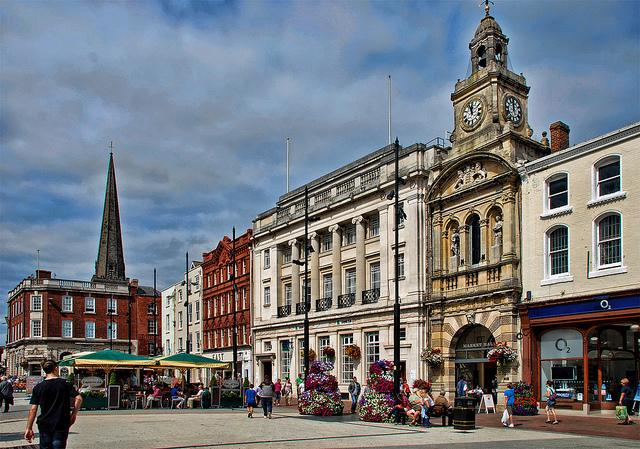How many clock faces can be seen on the clock tower? two 